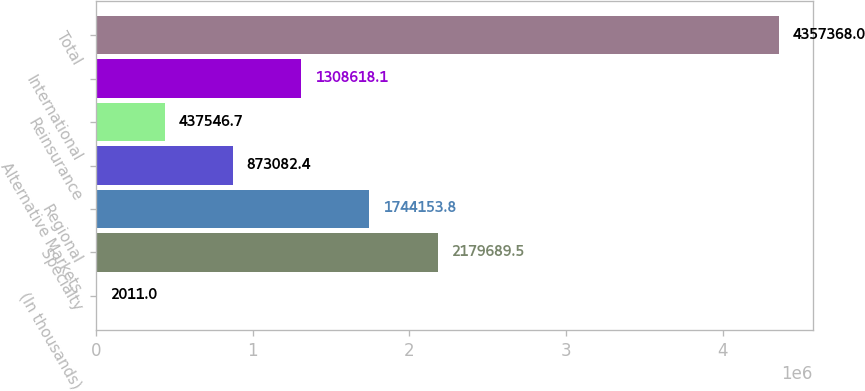Convert chart to OTSL. <chart><loc_0><loc_0><loc_500><loc_500><bar_chart><fcel>(In thousands)<fcel>Specialty<fcel>Regional<fcel>Alternative Markets<fcel>Reinsurance<fcel>International<fcel>Total<nl><fcel>2011<fcel>2.17969e+06<fcel>1.74415e+06<fcel>873082<fcel>437547<fcel>1.30862e+06<fcel>4.35737e+06<nl></chart> 